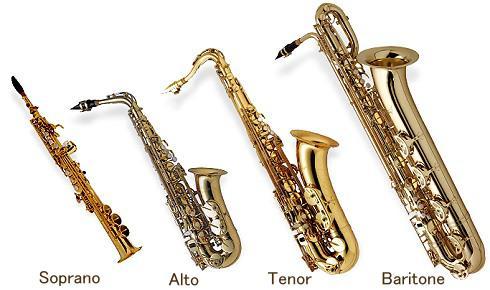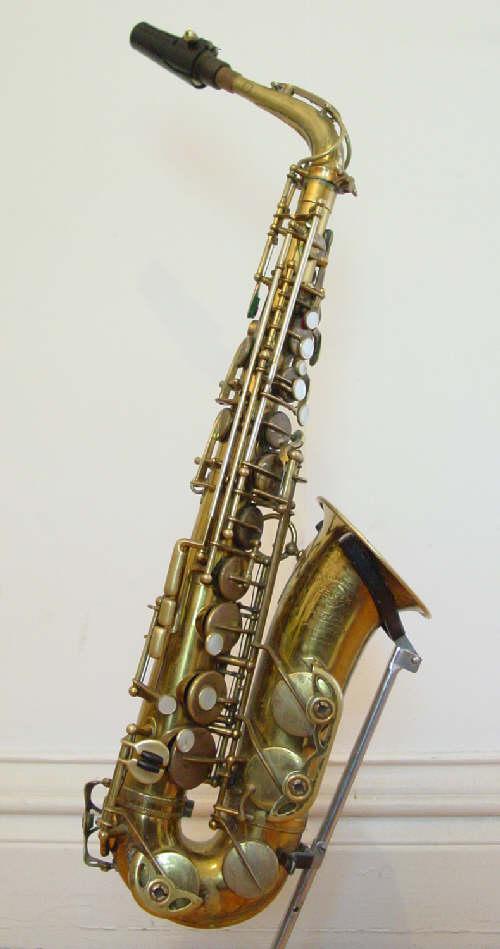The first image is the image on the left, the second image is the image on the right. Given the left and right images, does the statement "An image shows a row of at least four instruments, and the one on the far left does not have an upturned bell." hold true? Answer yes or no. Yes. 